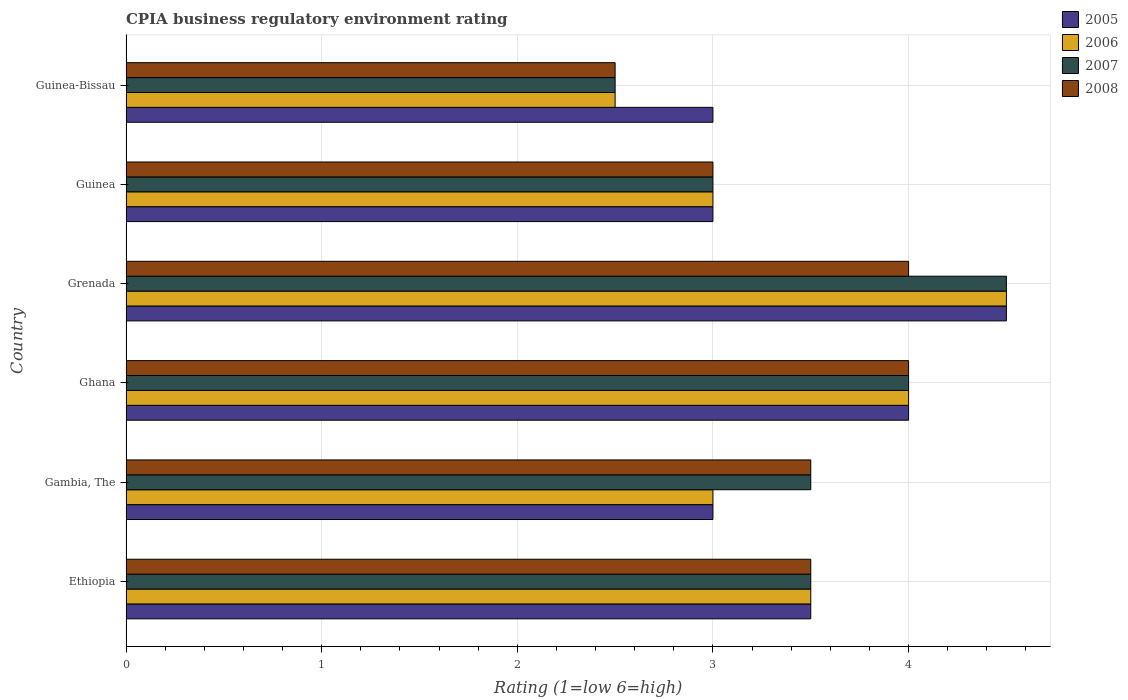How many groups of bars are there?
Ensure brevity in your answer.  6. Are the number of bars per tick equal to the number of legend labels?
Provide a succinct answer. Yes. How many bars are there on the 2nd tick from the top?
Your response must be concise. 4. What is the label of the 4th group of bars from the top?
Make the answer very short. Ghana. What is the CPIA rating in 2008 in Guinea-Bissau?
Make the answer very short. 2.5. Across all countries, what is the maximum CPIA rating in 2006?
Make the answer very short. 4.5. Across all countries, what is the minimum CPIA rating in 2007?
Your answer should be very brief. 2.5. In which country was the CPIA rating in 2006 maximum?
Make the answer very short. Grenada. In which country was the CPIA rating in 2005 minimum?
Provide a succinct answer. Gambia, The. What is the average CPIA rating in 2007 per country?
Offer a very short reply. 3.5. In how many countries, is the CPIA rating in 2007 greater than 3.6 ?
Ensure brevity in your answer.  2. Is the CPIA rating in 2006 in Ethiopia less than that in Ghana?
Your answer should be compact. Yes. What is the difference between the highest and the second highest CPIA rating in 2006?
Provide a short and direct response. 0.5. What is the difference between the highest and the lowest CPIA rating in 2007?
Ensure brevity in your answer.  2. In how many countries, is the CPIA rating in 2005 greater than the average CPIA rating in 2005 taken over all countries?
Ensure brevity in your answer.  2. Is it the case that in every country, the sum of the CPIA rating in 2008 and CPIA rating in 2005 is greater than the sum of CPIA rating in 2006 and CPIA rating in 2007?
Make the answer very short. No. What does the 2nd bar from the top in Ghana represents?
Your response must be concise. 2007. What does the 3rd bar from the bottom in Ethiopia represents?
Give a very brief answer. 2007. Is it the case that in every country, the sum of the CPIA rating in 2006 and CPIA rating in 2007 is greater than the CPIA rating in 2005?
Keep it short and to the point. Yes. Are all the bars in the graph horizontal?
Offer a very short reply. Yes. How many countries are there in the graph?
Offer a terse response. 6. Are the values on the major ticks of X-axis written in scientific E-notation?
Ensure brevity in your answer.  No. What is the title of the graph?
Ensure brevity in your answer.  CPIA business regulatory environment rating. Does "1979" appear as one of the legend labels in the graph?
Ensure brevity in your answer.  No. What is the label or title of the X-axis?
Provide a short and direct response. Rating (1=low 6=high). What is the label or title of the Y-axis?
Your answer should be very brief. Country. What is the Rating (1=low 6=high) in 2006 in Ethiopia?
Make the answer very short. 3.5. What is the Rating (1=low 6=high) of 2007 in Ethiopia?
Offer a terse response. 3.5. What is the Rating (1=low 6=high) in 2008 in Ethiopia?
Your answer should be very brief. 3.5. What is the Rating (1=low 6=high) in 2006 in Gambia, The?
Your response must be concise. 3. What is the Rating (1=low 6=high) of 2008 in Gambia, The?
Make the answer very short. 3.5. What is the Rating (1=low 6=high) of 2006 in Ghana?
Provide a short and direct response. 4. What is the Rating (1=low 6=high) of 2007 in Grenada?
Your answer should be very brief. 4.5. What is the Rating (1=low 6=high) of 2008 in Grenada?
Your answer should be compact. 4. What is the Rating (1=low 6=high) in 2005 in Guinea?
Provide a short and direct response. 3. What is the Rating (1=low 6=high) of 2006 in Guinea?
Keep it short and to the point. 3. What is the Rating (1=low 6=high) of 2007 in Guinea?
Make the answer very short. 3. What is the Rating (1=low 6=high) in 2005 in Guinea-Bissau?
Offer a terse response. 3. What is the Rating (1=low 6=high) of 2006 in Guinea-Bissau?
Your response must be concise. 2.5. What is the Rating (1=low 6=high) of 2007 in Guinea-Bissau?
Make the answer very short. 2.5. What is the Rating (1=low 6=high) of 2008 in Guinea-Bissau?
Provide a short and direct response. 2.5. Across all countries, what is the maximum Rating (1=low 6=high) of 2005?
Provide a succinct answer. 4.5. Across all countries, what is the maximum Rating (1=low 6=high) in 2007?
Provide a short and direct response. 4.5. Across all countries, what is the minimum Rating (1=low 6=high) of 2005?
Offer a very short reply. 3. Across all countries, what is the minimum Rating (1=low 6=high) in 2006?
Keep it short and to the point. 2.5. Across all countries, what is the minimum Rating (1=low 6=high) in 2007?
Provide a short and direct response. 2.5. Across all countries, what is the minimum Rating (1=low 6=high) in 2008?
Keep it short and to the point. 2.5. What is the total Rating (1=low 6=high) of 2005 in the graph?
Offer a terse response. 21. What is the total Rating (1=low 6=high) of 2006 in the graph?
Ensure brevity in your answer.  20.5. What is the difference between the Rating (1=low 6=high) in 2006 in Ethiopia and that in Gambia, The?
Your response must be concise. 0.5. What is the difference between the Rating (1=low 6=high) in 2007 in Ethiopia and that in Gambia, The?
Provide a short and direct response. 0. What is the difference between the Rating (1=low 6=high) in 2005 in Ethiopia and that in Ghana?
Your response must be concise. -0.5. What is the difference between the Rating (1=low 6=high) of 2006 in Ethiopia and that in Ghana?
Offer a terse response. -0.5. What is the difference between the Rating (1=low 6=high) of 2007 in Ethiopia and that in Ghana?
Provide a short and direct response. -0.5. What is the difference between the Rating (1=low 6=high) of 2008 in Ethiopia and that in Ghana?
Give a very brief answer. -0.5. What is the difference between the Rating (1=low 6=high) in 2005 in Ethiopia and that in Grenada?
Provide a short and direct response. -1. What is the difference between the Rating (1=low 6=high) in 2007 in Ethiopia and that in Guinea?
Your response must be concise. 0.5. What is the difference between the Rating (1=low 6=high) in 2005 in Gambia, The and that in Ghana?
Offer a very short reply. -1. What is the difference between the Rating (1=low 6=high) in 2007 in Gambia, The and that in Ghana?
Make the answer very short. -0.5. What is the difference between the Rating (1=low 6=high) of 2008 in Gambia, The and that in Ghana?
Your answer should be very brief. -0.5. What is the difference between the Rating (1=low 6=high) of 2007 in Gambia, The and that in Grenada?
Give a very brief answer. -1. What is the difference between the Rating (1=low 6=high) in 2008 in Gambia, The and that in Grenada?
Offer a terse response. -0.5. What is the difference between the Rating (1=low 6=high) in 2005 in Gambia, The and that in Guinea?
Give a very brief answer. 0. What is the difference between the Rating (1=low 6=high) of 2006 in Gambia, The and that in Guinea?
Keep it short and to the point. 0. What is the difference between the Rating (1=low 6=high) in 2007 in Gambia, The and that in Guinea?
Keep it short and to the point. 0.5. What is the difference between the Rating (1=low 6=high) of 2008 in Gambia, The and that in Guinea?
Your answer should be very brief. 0.5. What is the difference between the Rating (1=low 6=high) of 2005 in Gambia, The and that in Guinea-Bissau?
Provide a short and direct response. 0. What is the difference between the Rating (1=low 6=high) in 2006 in Gambia, The and that in Guinea-Bissau?
Your answer should be very brief. 0.5. What is the difference between the Rating (1=low 6=high) in 2005 in Ghana and that in Grenada?
Offer a terse response. -0.5. What is the difference between the Rating (1=low 6=high) in 2006 in Ghana and that in Grenada?
Your answer should be compact. -0.5. What is the difference between the Rating (1=low 6=high) of 2006 in Ghana and that in Guinea?
Make the answer very short. 1. What is the difference between the Rating (1=low 6=high) of 2007 in Ghana and that in Guinea?
Ensure brevity in your answer.  1. What is the difference between the Rating (1=low 6=high) of 2005 in Ghana and that in Guinea-Bissau?
Offer a very short reply. 1. What is the difference between the Rating (1=low 6=high) in 2006 in Ghana and that in Guinea-Bissau?
Your response must be concise. 1.5. What is the difference between the Rating (1=low 6=high) of 2007 in Ghana and that in Guinea-Bissau?
Ensure brevity in your answer.  1.5. What is the difference between the Rating (1=low 6=high) of 2005 in Grenada and that in Guinea?
Give a very brief answer. 1.5. What is the difference between the Rating (1=low 6=high) of 2007 in Grenada and that in Guinea?
Provide a short and direct response. 1.5. What is the difference between the Rating (1=low 6=high) in 2006 in Grenada and that in Guinea-Bissau?
Keep it short and to the point. 2. What is the difference between the Rating (1=low 6=high) of 2007 in Grenada and that in Guinea-Bissau?
Your answer should be very brief. 2. What is the difference between the Rating (1=low 6=high) in 2008 in Grenada and that in Guinea-Bissau?
Provide a succinct answer. 1.5. What is the difference between the Rating (1=low 6=high) of 2006 in Guinea and that in Guinea-Bissau?
Offer a terse response. 0.5. What is the difference between the Rating (1=low 6=high) in 2007 in Guinea and that in Guinea-Bissau?
Your answer should be compact. 0.5. What is the difference between the Rating (1=low 6=high) of 2005 in Ethiopia and the Rating (1=low 6=high) of 2006 in Gambia, The?
Your answer should be compact. 0.5. What is the difference between the Rating (1=low 6=high) of 2005 in Ethiopia and the Rating (1=low 6=high) of 2007 in Gambia, The?
Your response must be concise. 0. What is the difference between the Rating (1=low 6=high) of 2005 in Ethiopia and the Rating (1=low 6=high) of 2008 in Gambia, The?
Keep it short and to the point. 0. What is the difference between the Rating (1=low 6=high) in 2007 in Ethiopia and the Rating (1=low 6=high) in 2008 in Gambia, The?
Your response must be concise. 0. What is the difference between the Rating (1=low 6=high) in 2005 in Ethiopia and the Rating (1=low 6=high) in 2006 in Ghana?
Your response must be concise. -0.5. What is the difference between the Rating (1=low 6=high) in 2005 in Ethiopia and the Rating (1=low 6=high) in 2008 in Ghana?
Offer a terse response. -0.5. What is the difference between the Rating (1=low 6=high) in 2006 in Ethiopia and the Rating (1=low 6=high) in 2008 in Ghana?
Your response must be concise. -0.5. What is the difference between the Rating (1=low 6=high) in 2007 in Ethiopia and the Rating (1=low 6=high) in 2008 in Ghana?
Your answer should be very brief. -0.5. What is the difference between the Rating (1=low 6=high) in 2005 in Ethiopia and the Rating (1=low 6=high) in 2007 in Grenada?
Ensure brevity in your answer.  -1. What is the difference between the Rating (1=low 6=high) of 2005 in Ethiopia and the Rating (1=low 6=high) of 2008 in Grenada?
Your response must be concise. -0.5. What is the difference between the Rating (1=low 6=high) in 2006 in Ethiopia and the Rating (1=low 6=high) in 2007 in Grenada?
Provide a succinct answer. -1. What is the difference between the Rating (1=low 6=high) in 2006 in Ethiopia and the Rating (1=low 6=high) in 2008 in Grenada?
Your answer should be very brief. -0.5. What is the difference between the Rating (1=low 6=high) in 2007 in Ethiopia and the Rating (1=low 6=high) in 2008 in Grenada?
Provide a short and direct response. -0.5. What is the difference between the Rating (1=low 6=high) in 2006 in Ethiopia and the Rating (1=low 6=high) in 2008 in Guinea?
Give a very brief answer. 0.5. What is the difference between the Rating (1=low 6=high) of 2005 in Ethiopia and the Rating (1=low 6=high) of 2007 in Guinea-Bissau?
Offer a very short reply. 1. What is the difference between the Rating (1=low 6=high) of 2005 in Ethiopia and the Rating (1=low 6=high) of 2008 in Guinea-Bissau?
Make the answer very short. 1. What is the difference between the Rating (1=low 6=high) of 2006 in Ethiopia and the Rating (1=low 6=high) of 2008 in Guinea-Bissau?
Make the answer very short. 1. What is the difference between the Rating (1=low 6=high) in 2007 in Ethiopia and the Rating (1=low 6=high) in 2008 in Guinea-Bissau?
Provide a succinct answer. 1. What is the difference between the Rating (1=low 6=high) of 2005 in Gambia, The and the Rating (1=low 6=high) of 2007 in Ghana?
Keep it short and to the point. -1. What is the difference between the Rating (1=low 6=high) of 2006 in Gambia, The and the Rating (1=low 6=high) of 2007 in Ghana?
Keep it short and to the point. -1. What is the difference between the Rating (1=low 6=high) in 2007 in Gambia, The and the Rating (1=low 6=high) in 2008 in Ghana?
Your answer should be compact. -0.5. What is the difference between the Rating (1=low 6=high) in 2005 in Gambia, The and the Rating (1=low 6=high) in 2006 in Grenada?
Provide a succinct answer. -1.5. What is the difference between the Rating (1=low 6=high) of 2005 in Gambia, The and the Rating (1=low 6=high) of 2007 in Grenada?
Your answer should be compact. -1.5. What is the difference between the Rating (1=low 6=high) of 2005 in Gambia, The and the Rating (1=low 6=high) of 2008 in Grenada?
Offer a very short reply. -1. What is the difference between the Rating (1=low 6=high) in 2006 in Gambia, The and the Rating (1=low 6=high) in 2007 in Grenada?
Provide a succinct answer. -1.5. What is the difference between the Rating (1=low 6=high) of 2007 in Gambia, The and the Rating (1=low 6=high) of 2008 in Grenada?
Give a very brief answer. -0.5. What is the difference between the Rating (1=low 6=high) in 2005 in Gambia, The and the Rating (1=low 6=high) in 2006 in Guinea?
Your answer should be very brief. 0. What is the difference between the Rating (1=low 6=high) in 2005 in Gambia, The and the Rating (1=low 6=high) in 2007 in Guinea?
Make the answer very short. 0. What is the difference between the Rating (1=low 6=high) in 2005 in Gambia, The and the Rating (1=low 6=high) in 2008 in Guinea?
Provide a succinct answer. 0. What is the difference between the Rating (1=low 6=high) in 2006 in Gambia, The and the Rating (1=low 6=high) in 2008 in Guinea?
Offer a very short reply. 0. What is the difference between the Rating (1=low 6=high) of 2005 in Gambia, The and the Rating (1=low 6=high) of 2007 in Guinea-Bissau?
Provide a short and direct response. 0.5. What is the difference between the Rating (1=low 6=high) of 2006 in Gambia, The and the Rating (1=low 6=high) of 2008 in Guinea-Bissau?
Offer a very short reply. 0.5. What is the difference between the Rating (1=low 6=high) in 2005 in Ghana and the Rating (1=low 6=high) in 2006 in Guinea?
Offer a very short reply. 1. What is the difference between the Rating (1=low 6=high) in 2005 in Ghana and the Rating (1=low 6=high) in 2007 in Guinea?
Keep it short and to the point. 1. What is the difference between the Rating (1=low 6=high) in 2006 in Ghana and the Rating (1=low 6=high) in 2007 in Guinea?
Offer a very short reply. 1. What is the difference between the Rating (1=low 6=high) of 2005 in Ghana and the Rating (1=low 6=high) of 2006 in Guinea-Bissau?
Provide a short and direct response. 1.5. What is the difference between the Rating (1=low 6=high) in 2005 in Ghana and the Rating (1=low 6=high) in 2007 in Guinea-Bissau?
Keep it short and to the point. 1.5. What is the difference between the Rating (1=low 6=high) in 2005 in Grenada and the Rating (1=low 6=high) in 2006 in Guinea?
Your answer should be compact. 1.5. What is the difference between the Rating (1=low 6=high) of 2005 in Grenada and the Rating (1=low 6=high) of 2007 in Guinea?
Offer a terse response. 1.5. What is the difference between the Rating (1=low 6=high) of 2005 in Grenada and the Rating (1=low 6=high) of 2008 in Guinea?
Give a very brief answer. 1.5. What is the difference between the Rating (1=low 6=high) in 2006 in Grenada and the Rating (1=low 6=high) in 2008 in Guinea?
Make the answer very short. 1.5. What is the difference between the Rating (1=low 6=high) of 2007 in Grenada and the Rating (1=low 6=high) of 2008 in Guinea?
Offer a very short reply. 1.5. What is the difference between the Rating (1=low 6=high) in 2005 in Grenada and the Rating (1=low 6=high) in 2007 in Guinea-Bissau?
Make the answer very short. 2. What is the difference between the Rating (1=low 6=high) in 2006 in Grenada and the Rating (1=low 6=high) in 2008 in Guinea-Bissau?
Make the answer very short. 2. What is the difference between the Rating (1=low 6=high) in 2006 in Guinea and the Rating (1=low 6=high) in 2007 in Guinea-Bissau?
Offer a terse response. 0.5. What is the average Rating (1=low 6=high) in 2006 per country?
Provide a succinct answer. 3.42. What is the average Rating (1=low 6=high) of 2007 per country?
Your answer should be compact. 3.5. What is the average Rating (1=low 6=high) in 2008 per country?
Your response must be concise. 3.42. What is the difference between the Rating (1=low 6=high) of 2005 and Rating (1=low 6=high) of 2006 in Ethiopia?
Your answer should be very brief. 0. What is the difference between the Rating (1=low 6=high) in 2005 and Rating (1=low 6=high) in 2008 in Ethiopia?
Make the answer very short. 0. What is the difference between the Rating (1=low 6=high) of 2006 and Rating (1=low 6=high) of 2007 in Ethiopia?
Your response must be concise. 0. What is the difference between the Rating (1=low 6=high) in 2006 and Rating (1=low 6=high) in 2008 in Ethiopia?
Make the answer very short. 0. What is the difference between the Rating (1=low 6=high) of 2005 and Rating (1=low 6=high) of 2007 in Gambia, The?
Ensure brevity in your answer.  -0.5. What is the difference between the Rating (1=low 6=high) of 2005 and Rating (1=low 6=high) of 2008 in Gambia, The?
Ensure brevity in your answer.  -0.5. What is the difference between the Rating (1=low 6=high) in 2006 and Rating (1=low 6=high) in 2007 in Gambia, The?
Offer a very short reply. -0.5. What is the difference between the Rating (1=low 6=high) of 2006 and Rating (1=low 6=high) of 2008 in Gambia, The?
Provide a short and direct response. -0.5. What is the difference between the Rating (1=low 6=high) in 2007 and Rating (1=low 6=high) in 2008 in Gambia, The?
Provide a succinct answer. 0. What is the difference between the Rating (1=low 6=high) of 2005 and Rating (1=low 6=high) of 2008 in Ghana?
Provide a short and direct response. 0. What is the difference between the Rating (1=low 6=high) in 2005 and Rating (1=low 6=high) in 2006 in Grenada?
Provide a short and direct response. 0. What is the difference between the Rating (1=low 6=high) of 2005 and Rating (1=low 6=high) of 2008 in Grenada?
Offer a terse response. 0.5. What is the difference between the Rating (1=low 6=high) of 2006 and Rating (1=low 6=high) of 2007 in Grenada?
Keep it short and to the point. 0. What is the difference between the Rating (1=low 6=high) in 2006 and Rating (1=low 6=high) in 2008 in Grenada?
Your answer should be compact. 0.5. What is the difference between the Rating (1=low 6=high) of 2005 and Rating (1=low 6=high) of 2007 in Guinea?
Provide a short and direct response. 0. What is the difference between the Rating (1=low 6=high) of 2005 and Rating (1=low 6=high) of 2008 in Guinea?
Your answer should be compact. 0. What is the difference between the Rating (1=low 6=high) in 2006 and Rating (1=low 6=high) in 2007 in Guinea?
Offer a terse response. 0. What is the difference between the Rating (1=low 6=high) in 2006 and Rating (1=low 6=high) in 2008 in Guinea?
Your answer should be very brief. 0. What is the difference between the Rating (1=low 6=high) of 2005 and Rating (1=low 6=high) of 2006 in Guinea-Bissau?
Your answer should be very brief. 0.5. What is the difference between the Rating (1=low 6=high) in 2005 and Rating (1=low 6=high) in 2007 in Guinea-Bissau?
Offer a terse response. 0.5. What is the ratio of the Rating (1=low 6=high) of 2005 in Ethiopia to that in Gambia, The?
Make the answer very short. 1.17. What is the ratio of the Rating (1=low 6=high) of 2007 in Ethiopia to that in Gambia, The?
Your response must be concise. 1. What is the ratio of the Rating (1=low 6=high) of 2005 in Ethiopia to that in Ghana?
Keep it short and to the point. 0.88. What is the ratio of the Rating (1=low 6=high) of 2006 in Ethiopia to that in Ghana?
Provide a succinct answer. 0.88. What is the ratio of the Rating (1=low 6=high) of 2007 in Ethiopia to that in Ghana?
Your answer should be compact. 0.88. What is the ratio of the Rating (1=low 6=high) of 2008 in Ethiopia to that in Ghana?
Your answer should be compact. 0.88. What is the ratio of the Rating (1=low 6=high) in 2005 in Ethiopia to that in Grenada?
Keep it short and to the point. 0.78. What is the ratio of the Rating (1=low 6=high) of 2006 in Ethiopia to that in Grenada?
Provide a succinct answer. 0.78. What is the ratio of the Rating (1=low 6=high) in 2007 in Ethiopia to that in Grenada?
Keep it short and to the point. 0.78. What is the ratio of the Rating (1=low 6=high) of 2005 in Ethiopia to that in Guinea?
Keep it short and to the point. 1.17. What is the ratio of the Rating (1=low 6=high) of 2006 in Ethiopia to that in Guinea?
Make the answer very short. 1.17. What is the ratio of the Rating (1=low 6=high) of 2007 in Ethiopia to that in Guinea?
Provide a succinct answer. 1.17. What is the ratio of the Rating (1=low 6=high) in 2008 in Ethiopia to that in Guinea?
Ensure brevity in your answer.  1.17. What is the ratio of the Rating (1=low 6=high) of 2006 in Ethiopia to that in Guinea-Bissau?
Offer a very short reply. 1.4. What is the ratio of the Rating (1=low 6=high) of 2008 in Ethiopia to that in Guinea-Bissau?
Offer a very short reply. 1.4. What is the ratio of the Rating (1=low 6=high) in 2005 in Gambia, The to that in Ghana?
Your answer should be very brief. 0.75. What is the ratio of the Rating (1=low 6=high) of 2006 in Gambia, The to that in Grenada?
Offer a very short reply. 0.67. What is the ratio of the Rating (1=low 6=high) of 2008 in Gambia, The to that in Grenada?
Keep it short and to the point. 0.88. What is the ratio of the Rating (1=low 6=high) in 2005 in Gambia, The to that in Guinea?
Your response must be concise. 1. What is the ratio of the Rating (1=low 6=high) in 2008 in Gambia, The to that in Guinea?
Your answer should be very brief. 1.17. What is the ratio of the Rating (1=low 6=high) in 2005 in Gambia, The to that in Guinea-Bissau?
Your answer should be compact. 1. What is the ratio of the Rating (1=low 6=high) of 2006 in Gambia, The to that in Guinea-Bissau?
Offer a very short reply. 1.2. What is the ratio of the Rating (1=low 6=high) of 2007 in Gambia, The to that in Guinea-Bissau?
Provide a short and direct response. 1.4. What is the ratio of the Rating (1=low 6=high) in 2006 in Ghana to that in Grenada?
Provide a succinct answer. 0.89. What is the ratio of the Rating (1=low 6=high) of 2008 in Ghana to that in Grenada?
Provide a succinct answer. 1. What is the ratio of the Rating (1=low 6=high) of 2005 in Ghana to that in Guinea?
Make the answer very short. 1.33. What is the ratio of the Rating (1=low 6=high) of 2006 in Ghana to that in Guinea?
Your answer should be compact. 1.33. What is the ratio of the Rating (1=low 6=high) in 2007 in Ghana to that in Guinea?
Offer a very short reply. 1.33. What is the ratio of the Rating (1=low 6=high) in 2008 in Ghana to that in Guinea?
Ensure brevity in your answer.  1.33. What is the ratio of the Rating (1=low 6=high) in 2005 in Ghana to that in Guinea-Bissau?
Keep it short and to the point. 1.33. What is the ratio of the Rating (1=low 6=high) in 2006 in Ghana to that in Guinea-Bissau?
Provide a succinct answer. 1.6. What is the ratio of the Rating (1=low 6=high) of 2005 in Grenada to that in Guinea?
Provide a succinct answer. 1.5. What is the ratio of the Rating (1=low 6=high) in 2006 in Grenada to that in Guinea?
Ensure brevity in your answer.  1.5. What is the ratio of the Rating (1=low 6=high) in 2006 in Grenada to that in Guinea-Bissau?
Your answer should be very brief. 1.8. What is the ratio of the Rating (1=low 6=high) in 2007 in Grenada to that in Guinea-Bissau?
Make the answer very short. 1.8. What is the ratio of the Rating (1=low 6=high) in 2005 in Guinea to that in Guinea-Bissau?
Your response must be concise. 1. What is the ratio of the Rating (1=low 6=high) of 2008 in Guinea to that in Guinea-Bissau?
Your answer should be very brief. 1.2. What is the difference between the highest and the second highest Rating (1=low 6=high) in 2006?
Your answer should be very brief. 0.5. What is the difference between the highest and the lowest Rating (1=low 6=high) in 2005?
Provide a short and direct response. 1.5. What is the difference between the highest and the lowest Rating (1=low 6=high) in 2006?
Make the answer very short. 2. What is the difference between the highest and the lowest Rating (1=low 6=high) in 2007?
Give a very brief answer. 2. What is the difference between the highest and the lowest Rating (1=low 6=high) in 2008?
Keep it short and to the point. 1.5. 